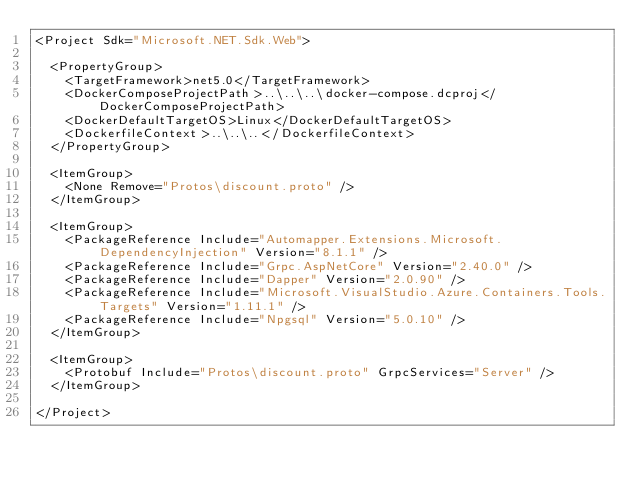<code> <loc_0><loc_0><loc_500><loc_500><_XML_><Project Sdk="Microsoft.NET.Sdk.Web">

  <PropertyGroup>
    <TargetFramework>net5.0</TargetFramework>
    <DockerComposeProjectPath>..\..\..\docker-compose.dcproj</DockerComposeProjectPath>
    <DockerDefaultTargetOS>Linux</DockerDefaultTargetOS>
    <DockerfileContext>..\..\..</DockerfileContext>
  </PropertyGroup>

  <ItemGroup>
    <None Remove="Protos\discount.proto" />
  </ItemGroup>

  <ItemGroup>
    <PackageReference Include="Automapper.Extensions.Microsoft.DependencyInjection" Version="8.1.1" />
    <PackageReference Include="Grpc.AspNetCore" Version="2.40.0" />
    <PackageReference Include="Dapper" Version="2.0.90" />
    <PackageReference Include="Microsoft.VisualStudio.Azure.Containers.Tools.Targets" Version="1.11.1" />
    <PackageReference Include="Npgsql" Version="5.0.10" />
  </ItemGroup>

  <ItemGroup>
    <Protobuf Include="Protos\discount.proto" GrpcServices="Server" />
  </ItemGroup>

</Project>
</code> 